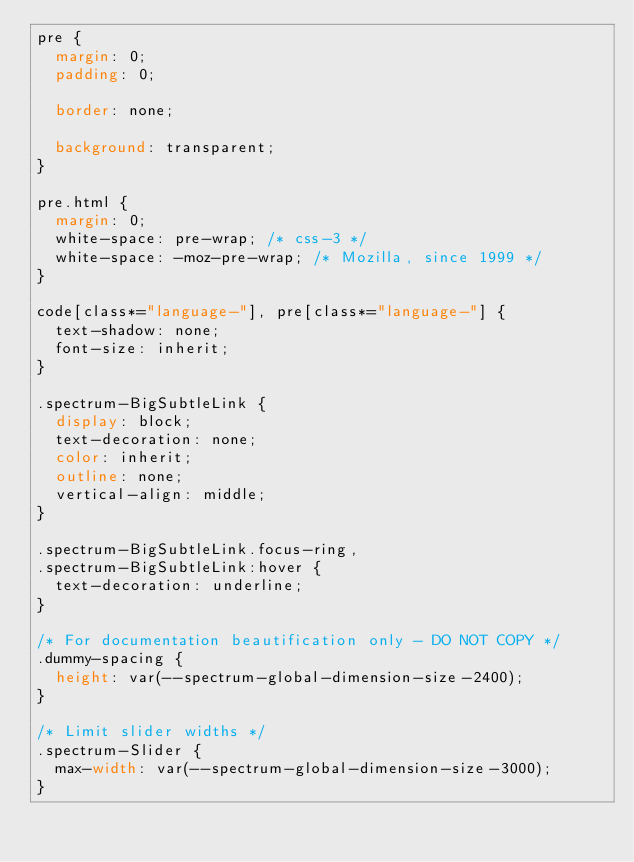<code> <loc_0><loc_0><loc_500><loc_500><_CSS_>pre {
  margin: 0;
  padding: 0;

  border: none;

  background: transparent;
}

pre.html {
  margin: 0;
  white-space: pre-wrap; /* css-3 */
  white-space: -moz-pre-wrap; /* Mozilla, since 1999 */
}

code[class*="language-"], pre[class*="language-"] {
  text-shadow: none;
  font-size: inherit;
}

.spectrum-BigSubtleLink {
  display: block;
  text-decoration: none;
  color: inherit;
  outline: none;
  vertical-align: middle;
}

.spectrum-BigSubtleLink.focus-ring,
.spectrum-BigSubtleLink:hover {
  text-decoration: underline;
}

/* For documentation beautification only - DO NOT COPY */
.dummy-spacing {
  height: var(--spectrum-global-dimension-size-2400);
}

/* Limit slider widths */
.spectrum-Slider {
  max-width: var(--spectrum-global-dimension-size-3000);
}
</code> 